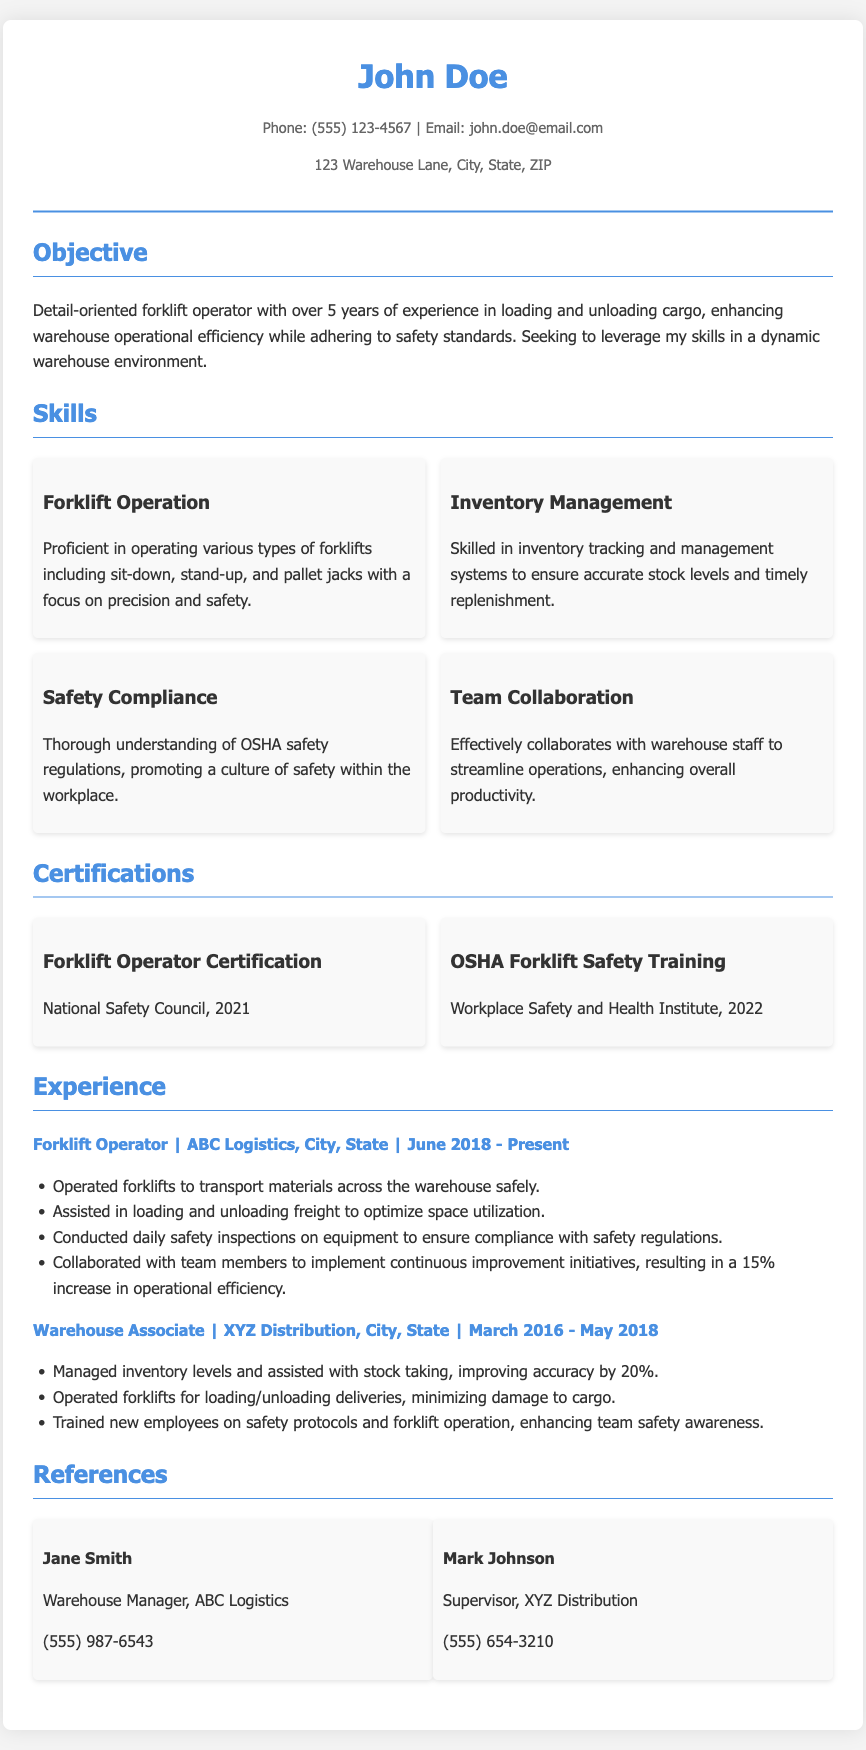What is the name of the forklift operator? The name is prominently displayed at the top of the document.
Answer: John Doe How many years of experience does John Doe have? The objective section states that he has over 5 years of experience.
Answer: 5 years What type of certification did John Doe receive in 2021? The certifications section lists this specific certification.
Answer: Forklift Operator Certification What percentage increase in operational efficiency was achieved at ABC Logistics? This information is provided in the experience section under his current job responsibilities.
Answer: 15% Which organization provided the OSHA Forklift Safety Training? The certifications section mentions the organization that conducted the training.
Answer: Workplace Safety and Health Institute What specific type of forklifts is John proficient in operating? The skills section details the types of forklifts mentioned.
Answer: Sit-down, stand-up, and pallet jacks In which company did John work as a Warehouse Associate? The experience section includes the name of the company for his previous position.
Answer: XYZ Distribution What safety regulation knowledge does John emphasize in his skills? The skills section highlights his knowledge regarding safety regulations.
Answer: OSHA safety regulations What is the main goal of John’s job as stated in his resume? The objective section outlines his goal in seeking employment.
Answer: Enhance warehouse operational efficiency 